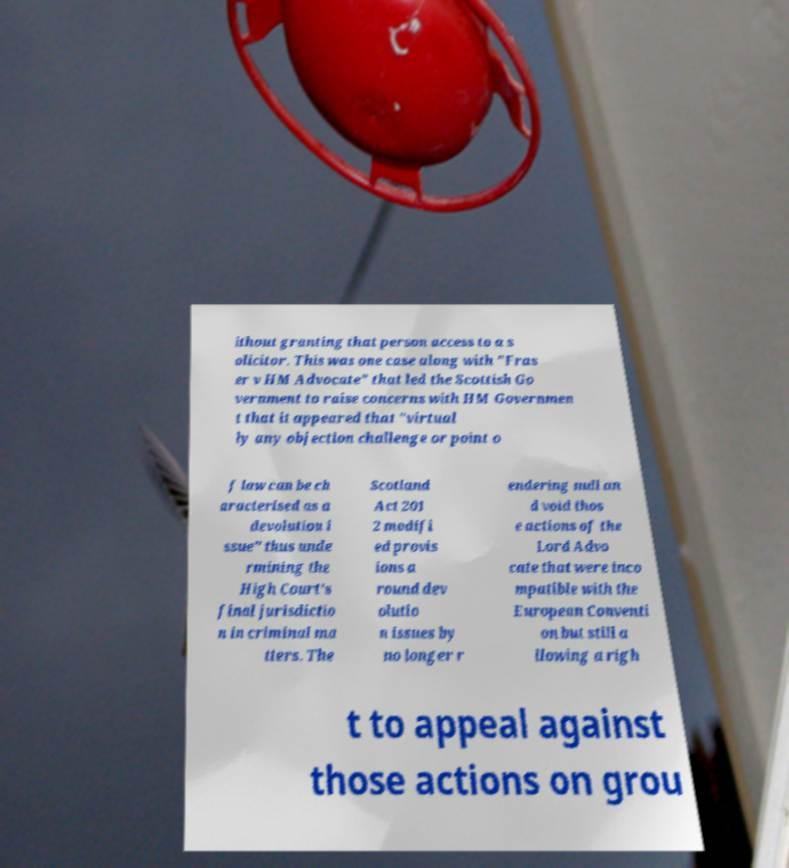Please read and relay the text visible in this image. What does it say? ithout granting that person access to a s olicitor. This was one case along with "Fras er v HM Advocate" that led the Scottish Go vernment to raise concerns with HM Governmen t that it appeared that "virtual ly any objection challenge or point o f law can be ch aracterised as a devolution i ssue" thus unde rmining the High Court's final jurisdictio n in criminal ma tters. The Scotland Act 201 2 modifi ed provis ions a round dev olutio n issues by no longer r endering null an d void thos e actions of the Lord Advo cate that were inco mpatible with the European Conventi on but still a llowing a righ t to appeal against those actions on grou 